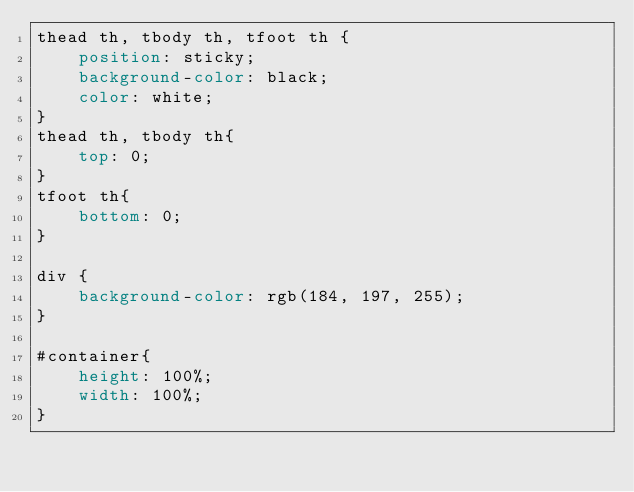Convert code to text. <code><loc_0><loc_0><loc_500><loc_500><_CSS_>thead th, tbody th, tfoot th { 
    position: sticky;     
    background-color: black;
    color: white;
}
thead th, tbody th{
    top: 0; 
}
tfoot th{
    bottom: 0; 
}

div {
    background-color: rgb(184, 197, 255);
}

#container{
    height: 100%;
    width: 100%;
}</code> 